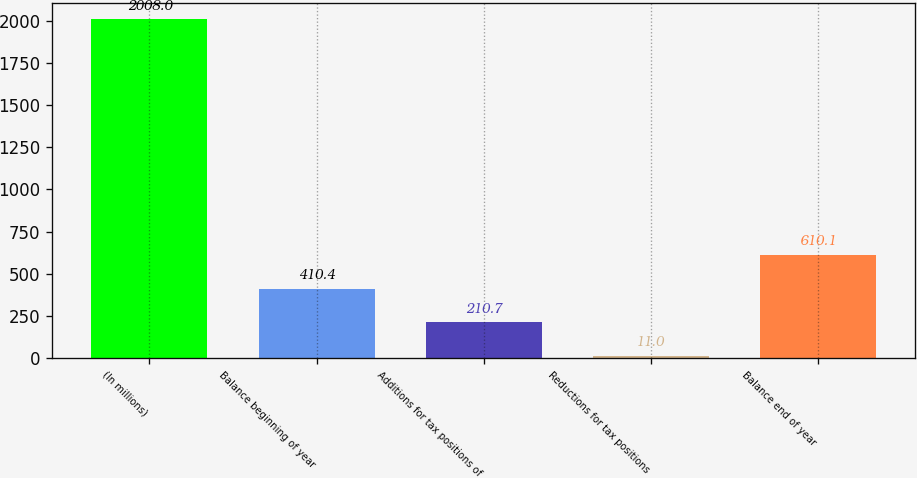<chart> <loc_0><loc_0><loc_500><loc_500><bar_chart><fcel>(In millions)<fcel>Balance beginning of year<fcel>Additions for tax positions of<fcel>Reductions for tax positions<fcel>Balance end of year<nl><fcel>2008<fcel>410.4<fcel>210.7<fcel>11<fcel>610.1<nl></chart> 